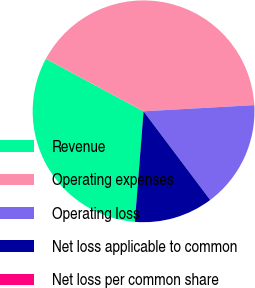Convert chart to OTSL. <chart><loc_0><loc_0><loc_500><loc_500><pie_chart><fcel>Revenue<fcel>Operating expenses<fcel>Operating loss<fcel>Net loss applicable to common<fcel>Net loss per common share<nl><fcel>31.6%<fcel>41.26%<fcel>15.63%<fcel>11.51%<fcel>0.0%<nl></chart> 